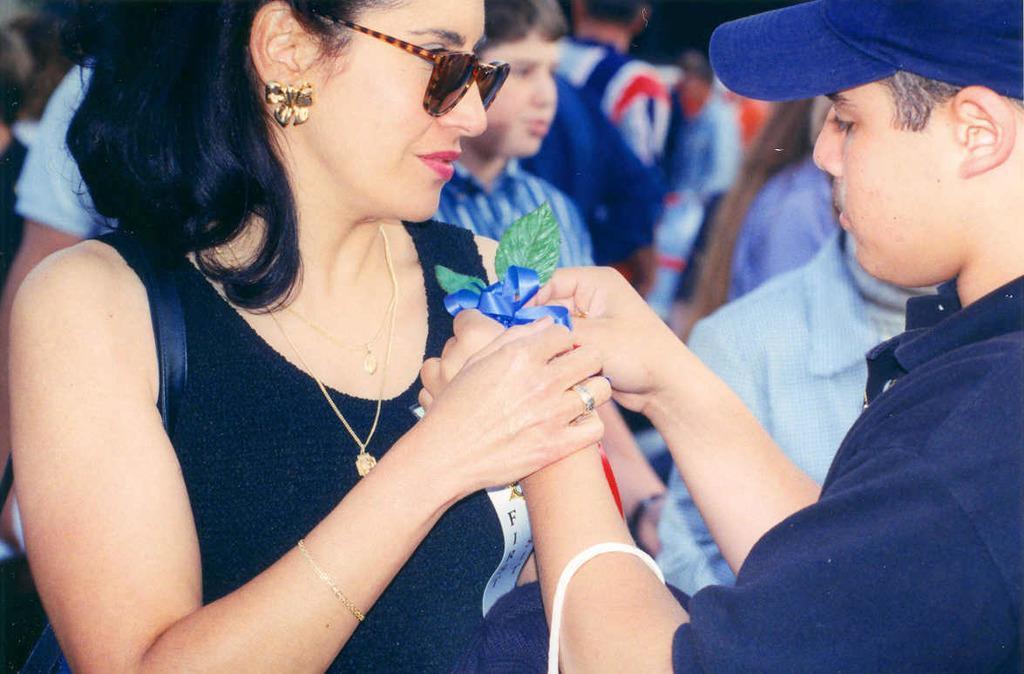Can you describe this image briefly? In this image I can see number of people are standing. In the front I can see one woman is wearing a shades and one man is wearing a blue colour cap. I can also see she is carrying a bag and he is holding an object. I can also see this image is little bit blurry in the background. 